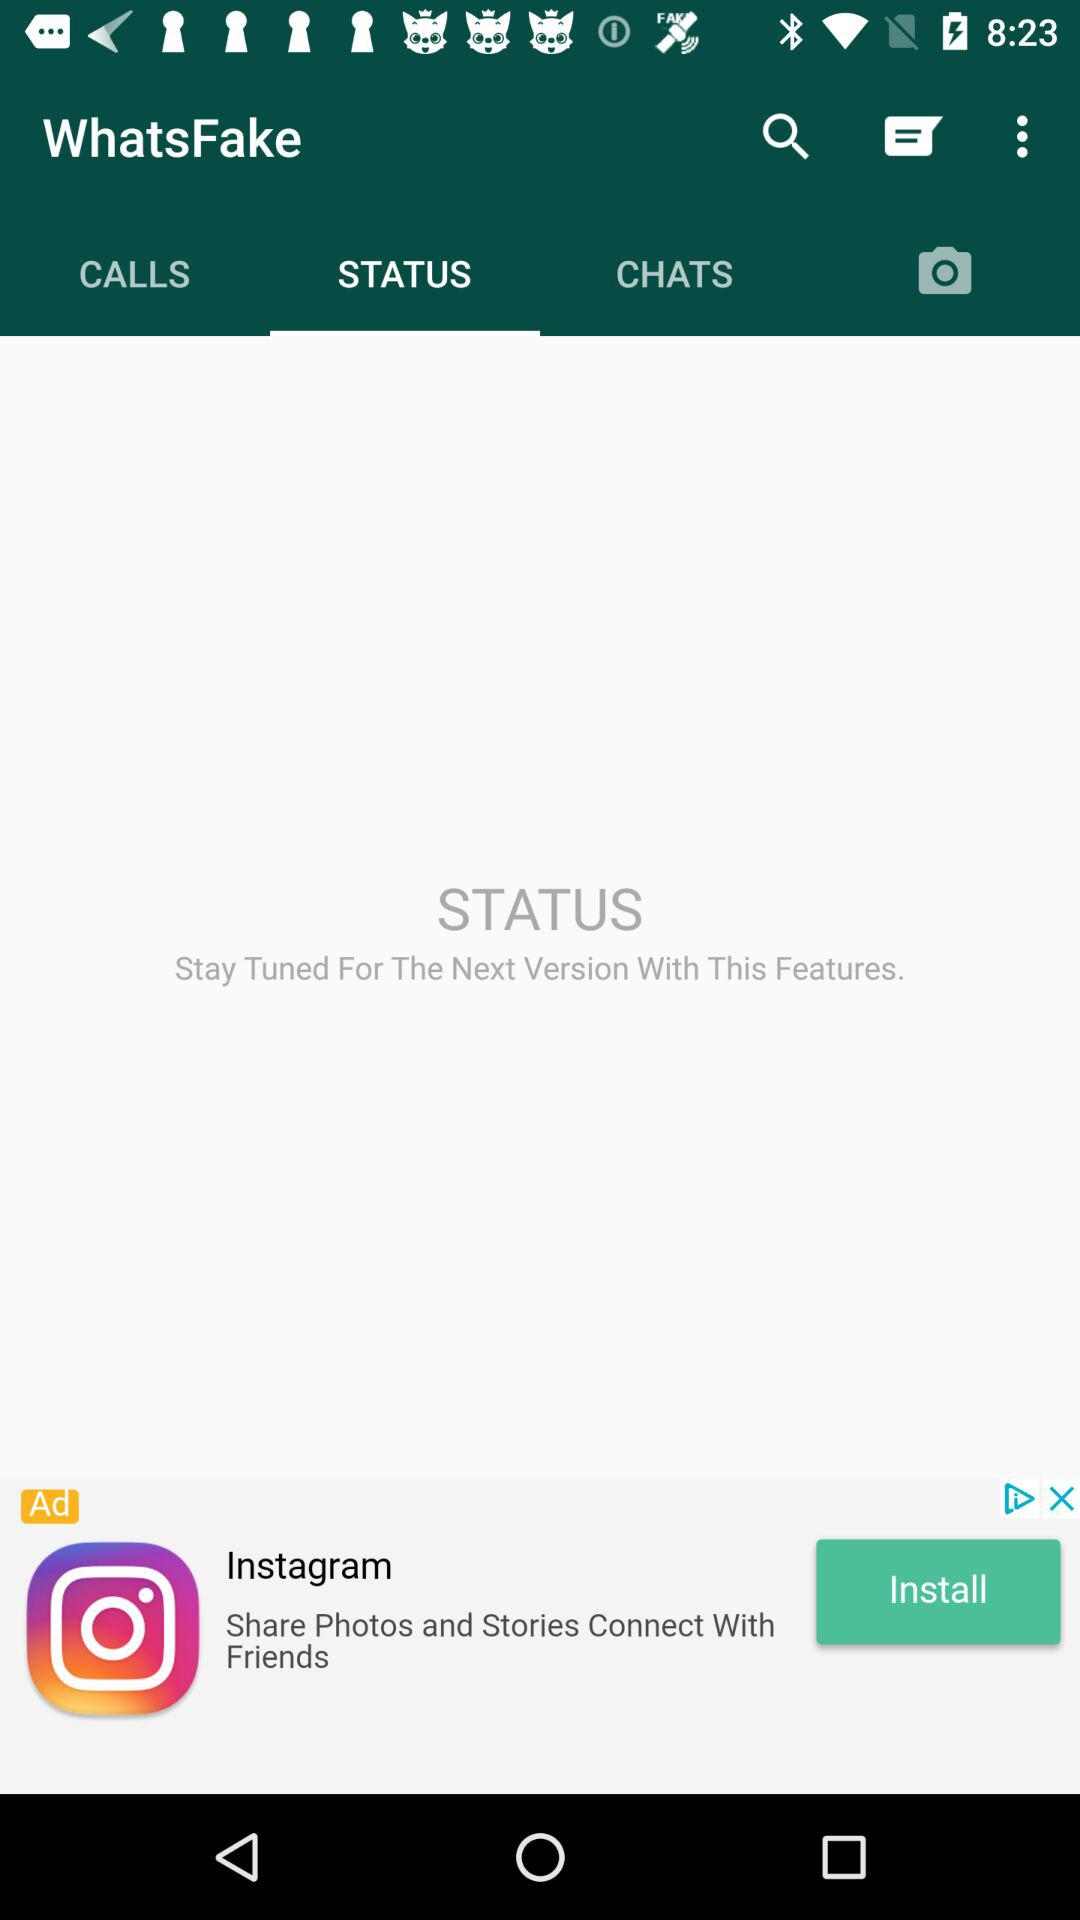What is the status?
When the provided information is insufficient, respond with <no answer>. <no answer> 